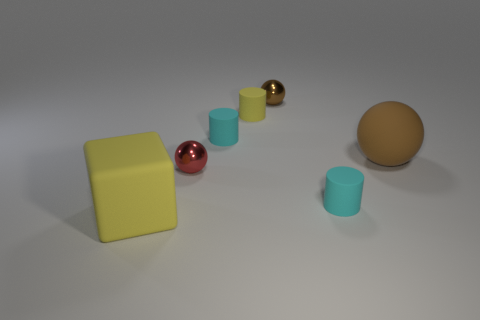Subtract all shiny balls. How many balls are left? 1 Subtract all cyan cylinders. How many cylinders are left? 1 Subtract 2 cylinders. How many cylinders are left? 1 Add 1 metal objects. How many objects exist? 8 Add 7 tiny rubber cylinders. How many tiny rubber cylinders exist? 10 Subtract 0 green balls. How many objects are left? 7 Subtract all blocks. How many objects are left? 6 Subtract all blue cylinders. Subtract all blue balls. How many cylinders are left? 3 Subtract all brown cylinders. How many brown balls are left? 2 Subtract all small cyan rubber cylinders. Subtract all small cyan things. How many objects are left? 3 